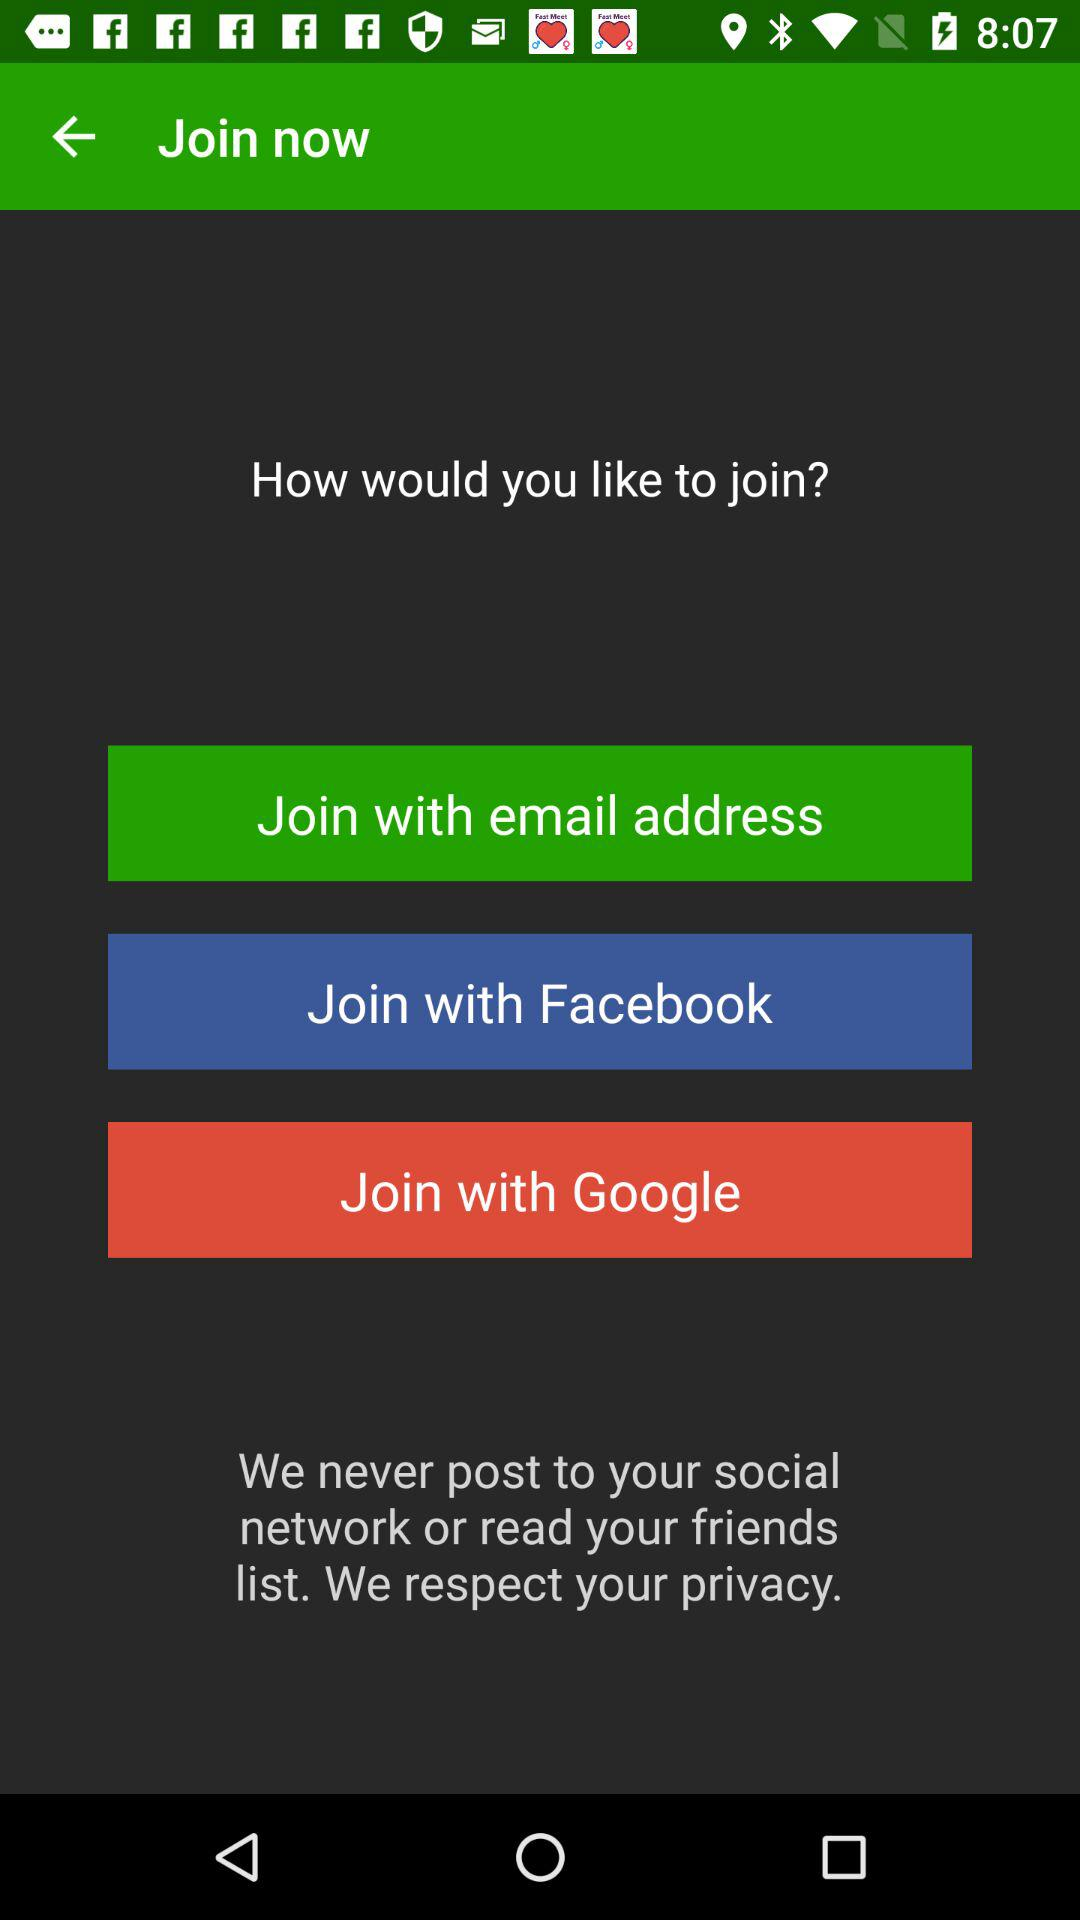With which accounts can the user join? The user can join with their "email address", "Facebook" and "Google" accounts. 